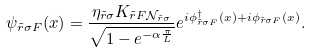Convert formula to latex. <formula><loc_0><loc_0><loc_500><loc_500>\psi _ { \tilde { r } \sigma F } ( x ) = \frac { \eta _ { \tilde { r } \sigma } K _ { \tilde { r } F \mathcal { N } _ { \tilde { r } \sigma } } } { \sqrt { 1 - e ^ { - \alpha \frac { \pi } { L } } } } e ^ { i \phi _ { \tilde { r } \sigma F } ^ { \dagger } ( x ) + i \phi _ { \tilde { r } \sigma F } ( x ) } .</formula> 